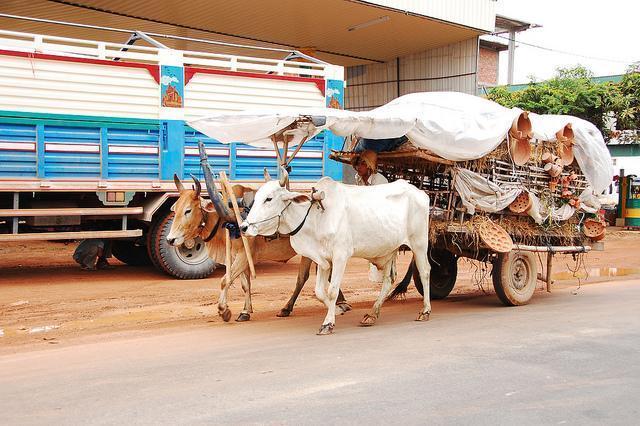How many cows can you see?
Give a very brief answer. 2. How many umbrellas are open?
Give a very brief answer. 0. 